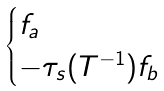<formula> <loc_0><loc_0><loc_500><loc_500>\begin{cases} f _ { a } & \\ - \tau _ { s } ( T ^ { - 1 } ) f _ { b } & \end{cases}</formula> 